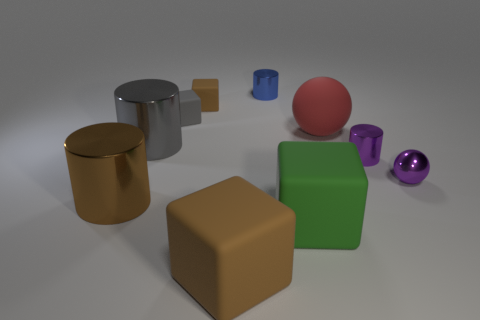Subtract all small purple cylinders. How many cylinders are left? 3 Subtract all gray cubes. How many cubes are left? 3 Subtract 2 cylinders. How many cylinders are left? 2 Subtract all gray balls. Subtract all large brown blocks. How many objects are left? 9 Add 1 green rubber things. How many green rubber things are left? 2 Add 8 gray shiny cylinders. How many gray shiny cylinders exist? 9 Subtract 1 purple balls. How many objects are left? 9 Subtract all cubes. How many objects are left? 6 Subtract all gray cubes. Subtract all blue cylinders. How many cubes are left? 3 Subtract all brown blocks. How many red cylinders are left? 0 